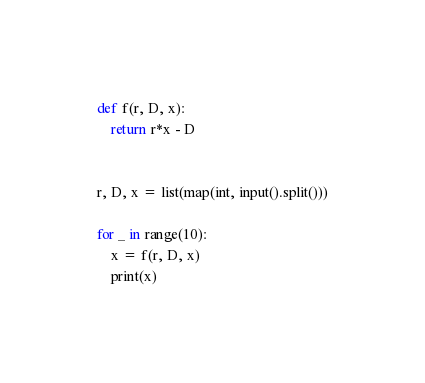Convert code to text. <code><loc_0><loc_0><loc_500><loc_500><_Python_>def f(r, D, x):
    return r*x - D


r, D, x = list(map(int, input().split()))

for _ in range(10):
    x = f(r, D, x)
    print(x)
</code> 